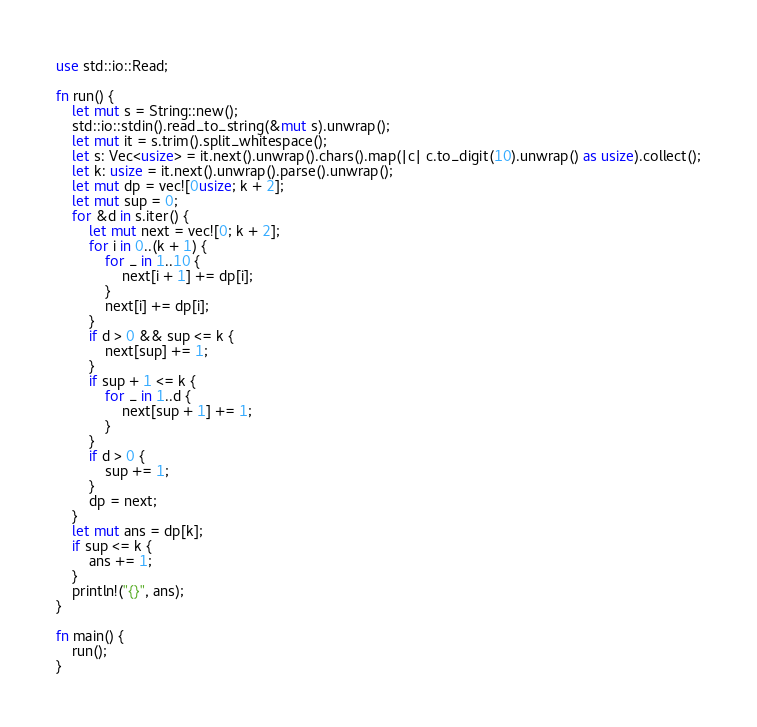<code> <loc_0><loc_0><loc_500><loc_500><_Rust_>use std::io::Read;

fn run() {
    let mut s = String::new();
    std::io::stdin().read_to_string(&mut s).unwrap();
    let mut it = s.trim().split_whitespace();
    let s: Vec<usize> = it.next().unwrap().chars().map(|c| c.to_digit(10).unwrap() as usize).collect();
    let k: usize = it.next().unwrap().parse().unwrap();
    let mut dp = vec![0usize; k + 2];
    let mut sup = 0;
    for &d in s.iter() {
        let mut next = vec![0; k + 2];
        for i in 0..(k + 1) {
            for _ in 1..10 {
                next[i + 1] += dp[i];
            }
            next[i] += dp[i];
        }
        if d > 0 && sup <= k {
            next[sup] += 1;
        }
        if sup + 1 <= k {
            for _ in 1..d {
                next[sup + 1] += 1;
            }
        }
        if d > 0 {
            sup += 1;
        }
        dp = next;
    }
    let mut ans = dp[k];
    if sup <= k {
        ans += 1;
    }
    println!("{}", ans);
}

fn main() {
    run();
}
</code> 